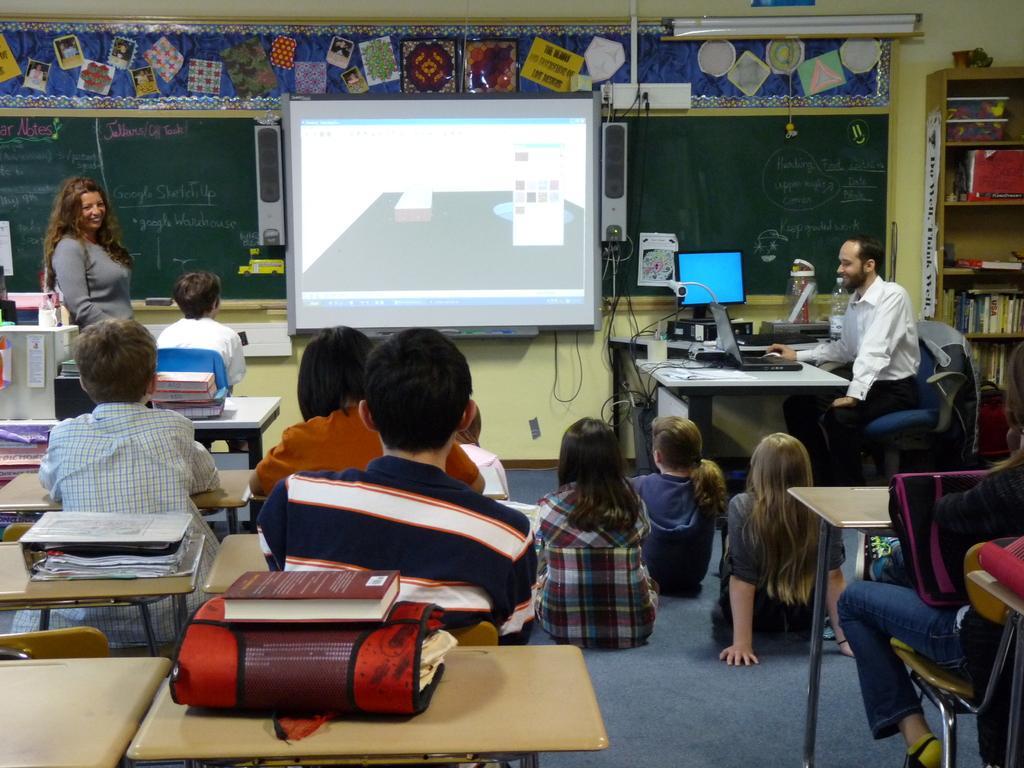Please provide a concise description of this image. This picture shows few of them seated on the chair and a woman standing and few of them seated on the floor and we see bags, books on the table and we see a man seated on the chair and we see a monitor and a keyboard on the another table and we see a projector screen and speakers on both sides of the projector and we see wooden bookshelf on the corner of the room. 